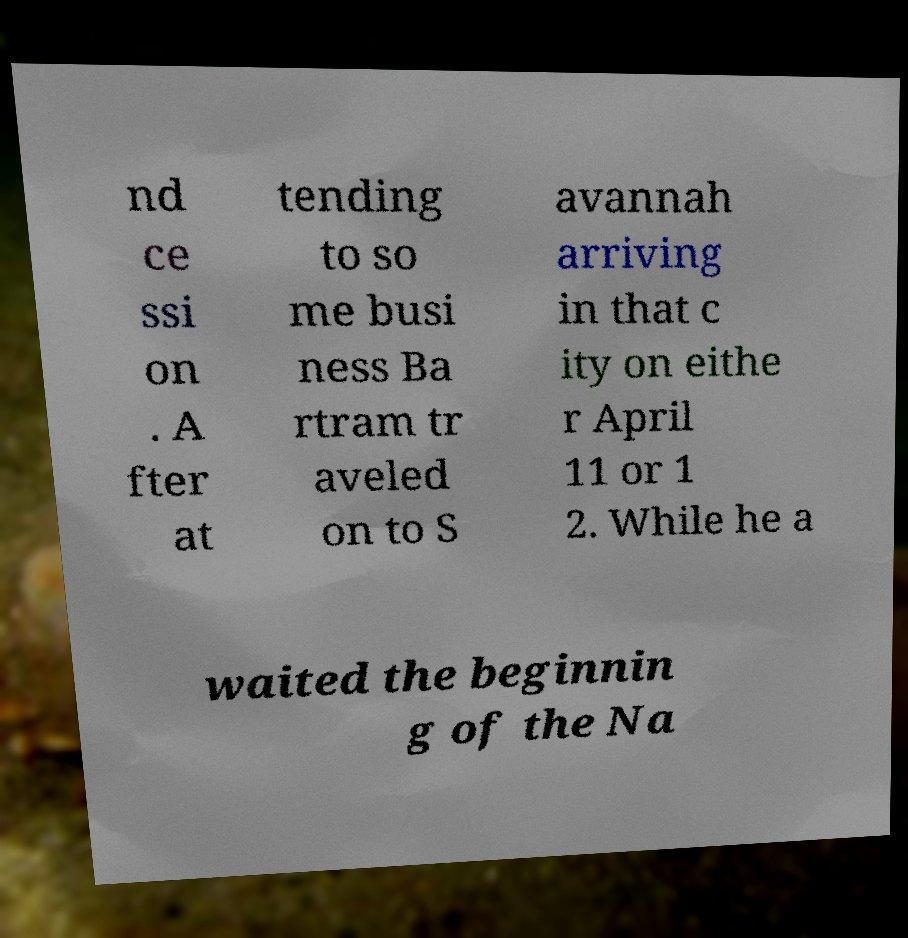Can you read and provide the text displayed in the image?This photo seems to have some interesting text. Can you extract and type it out for me? nd ce ssi on . A fter at tending to so me busi ness Ba rtram tr aveled on to S avannah arriving in that c ity on eithe r April 11 or 1 2. While he a waited the beginnin g of the Na 